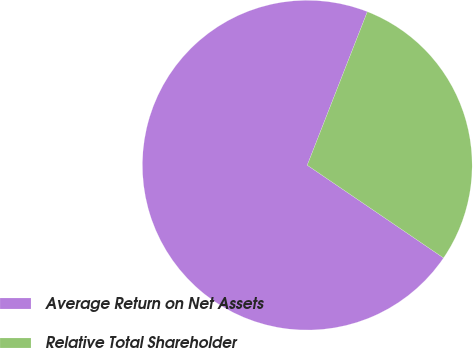<chart> <loc_0><loc_0><loc_500><loc_500><pie_chart><fcel>Average Return on Net Assets<fcel>Relative Total Shareholder<nl><fcel>71.43%<fcel>28.57%<nl></chart> 